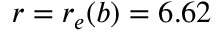Convert formula to latex. <formula><loc_0><loc_0><loc_500><loc_500>r = r _ { e } ( b ) = 6 . 6 2</formula> 